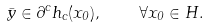Convert formula to latex. <formula><loc_0><loc_0><loc_500><loc_500>\bar { y } \in \partial ^ { c } h _ { c } ( x _ { 0 } ) , \quad \forall x _ { 0 } \in H .</formula> 